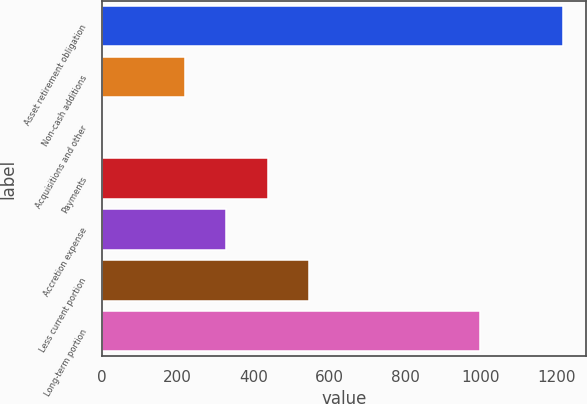<chart> <loc_0><loc_0><loc_500><loc_500><bar_chart><fcel>Asset retirement obligation<fcel>Non-cash additions<fcel>Acquisitions and other<fcel>Payments<fcel>Accretion expense<fcel>Less current portion<fcel>Long-term portion<nl><fcel>1215.84<fcel>218.74<fcel>0.6<fcel>436.88<fcel>327.81<fcel>545.95<fcel>997.7<nl></chart> 